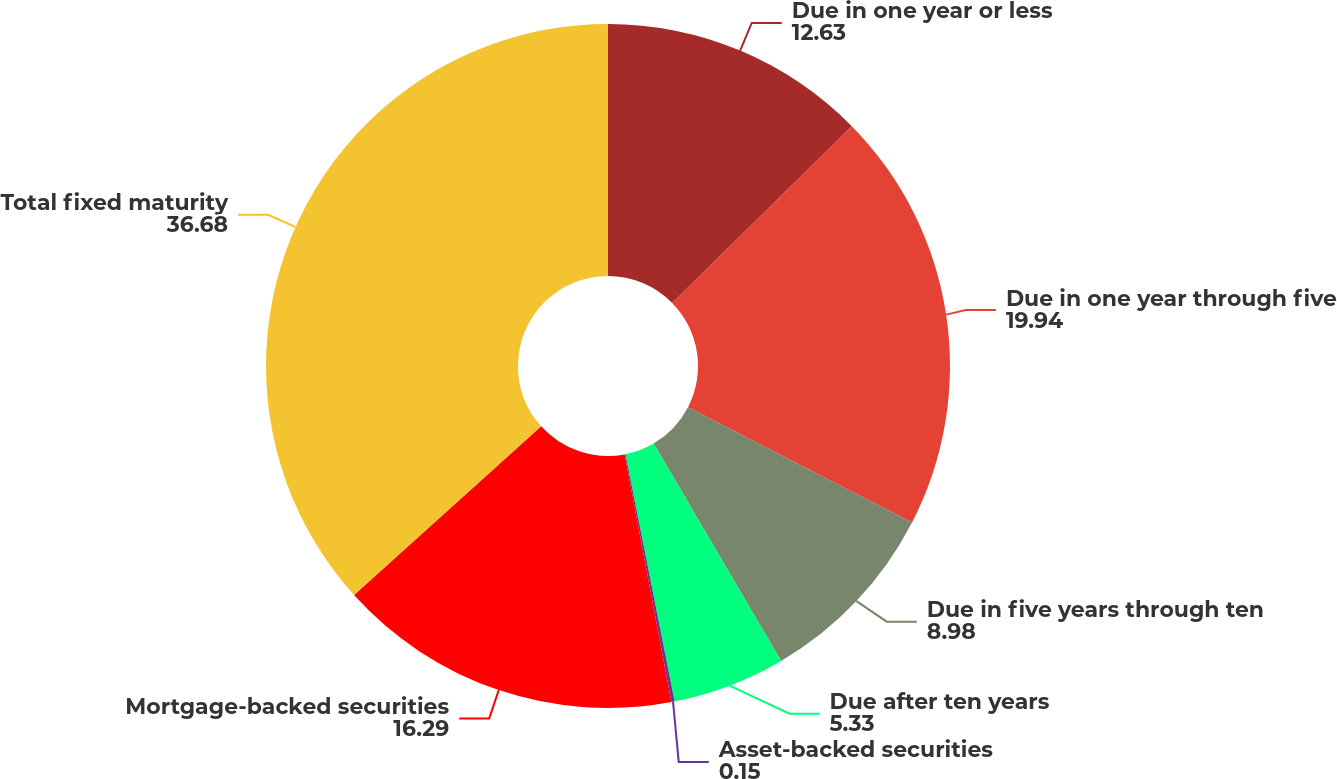<chart> <loc_0><loc_0><loc_500><loc_500><pie_chart><fcel>Due in one year or less<fcel>Due in one year through five<fcel>Due in five years through ten<fcel>Due after ten years<fcel>Asset-backed securities<fcel>Mortgage-backed securities<fcel>Total fixed maturity<nl><fcel>12.63%<fcel>19.94%<fcel>8.98%<fcel>5.33%<fcel>0.15%<fcel>16.29%<fcel>36.68%<nl></chart> 